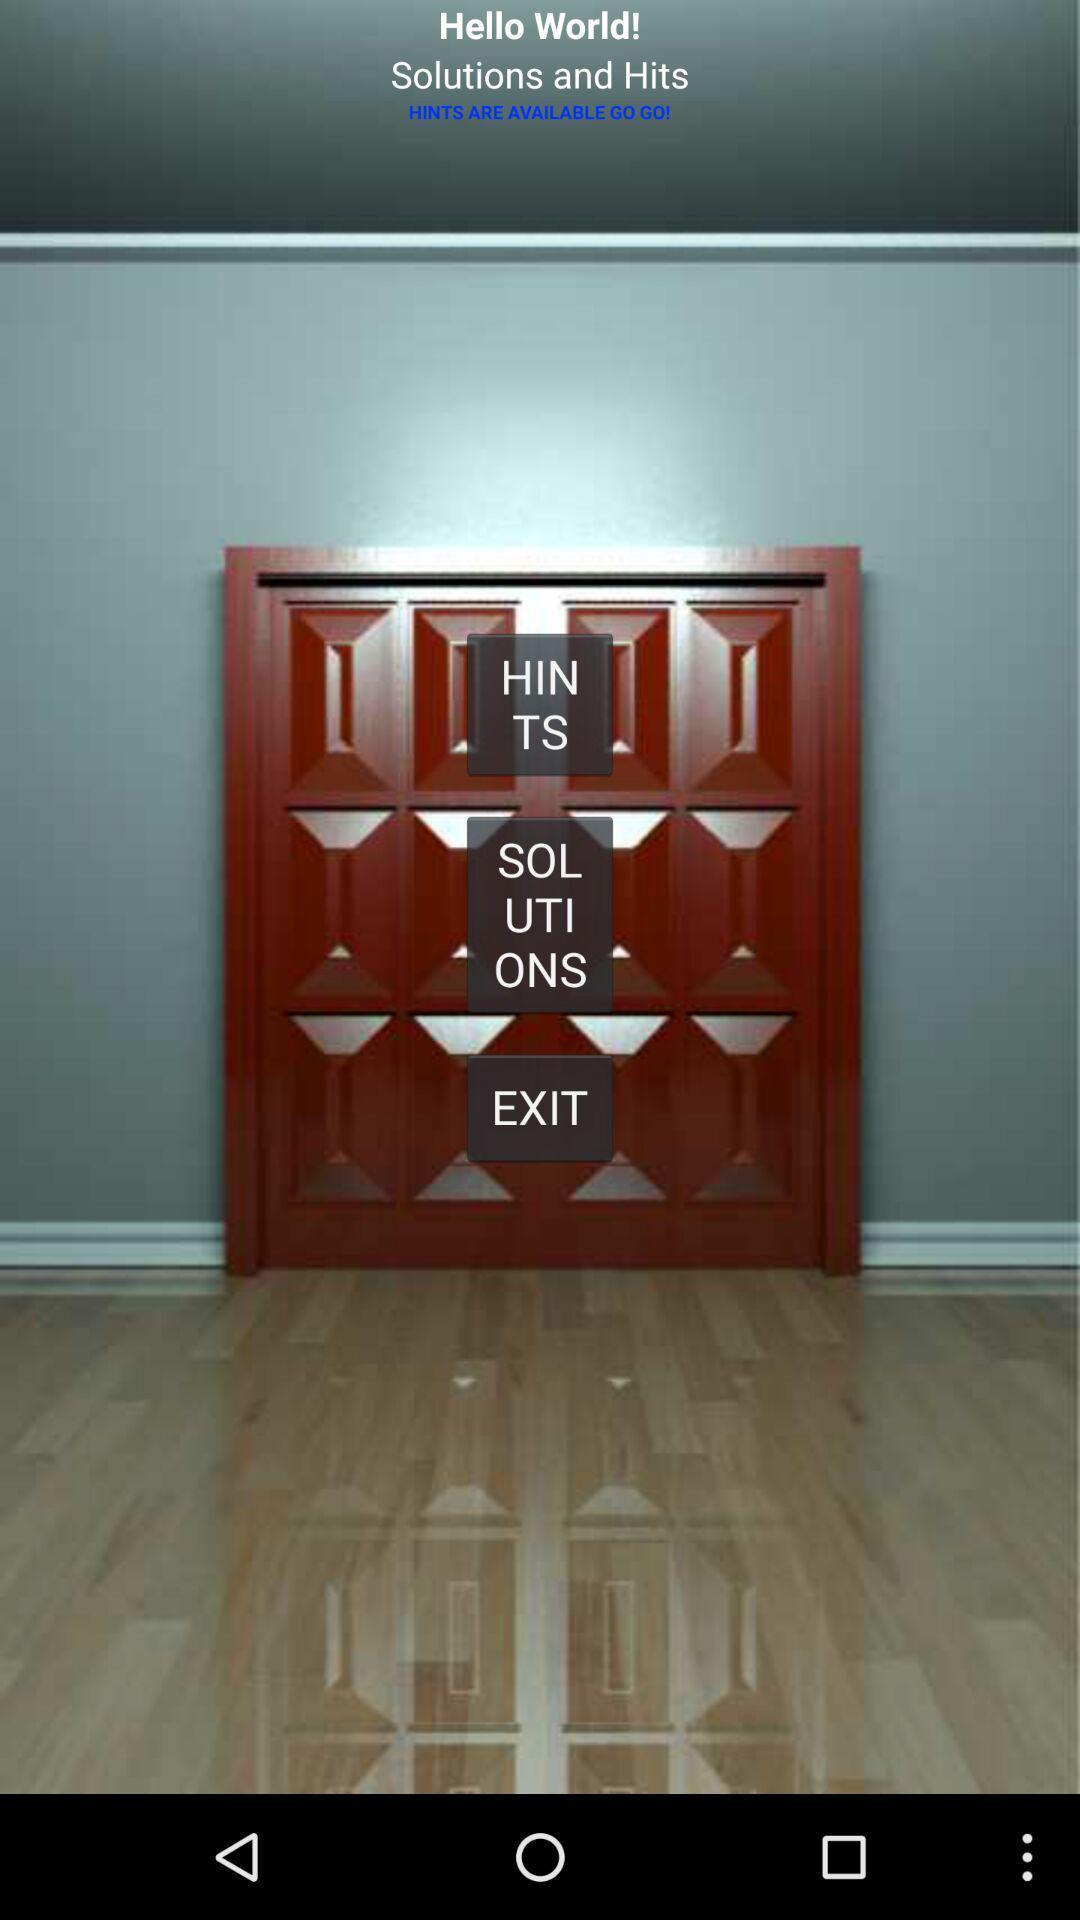Give me a summary of this screen capture. Page showing an image of door. 